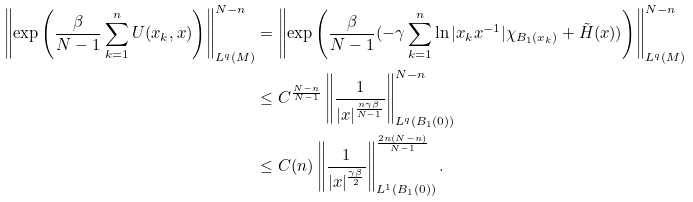Convert formula to latex. <formula><loc_0><loc_0><loc_500><loc_500>\left \| \exp { \left ( \frac { \beta } { N - 1 } \sum _ { k = 1 } ^ { n } U ( x _ { k } , x ) \right ) } \right \| _ { L ^ { q } ( M ) } ^ { N - n } & = \left \| \exp { \left ( \frac { \beta } { N - 1 } ( - \gamma \sum _ { k = 1 } ^ { n } \ln | x _ { k } x ^ { - 1 } | \chi _ { B _ { 1 } ( x _ { k } ) } + \tilde { H } ( x ) ) \right ) } \right \| _ { L ^ { q } ( M ) } ^ { N - n } \\ & \leq C ^ { \frac { N - n } { N - 1 } } \left \| \frac { 1 } { | x | ^ { \frac { n \gamma \beta } { N - 1 } } } \right \| _ { L ^ { q } ( B _ { 1 } ( 0 ) ) } ^ { N - n } \\ & \leq C ( n ) \left \| \frac { 1 } { | x | ^ { \frac { \gamma \beta } { 2 } } } \right \| _ { L ^ { 1 } ( B _ { 1 } ( 0 ) ) } ^ { \frac { 2 n ( N - n ) } { N - 1 } } .</formula> 